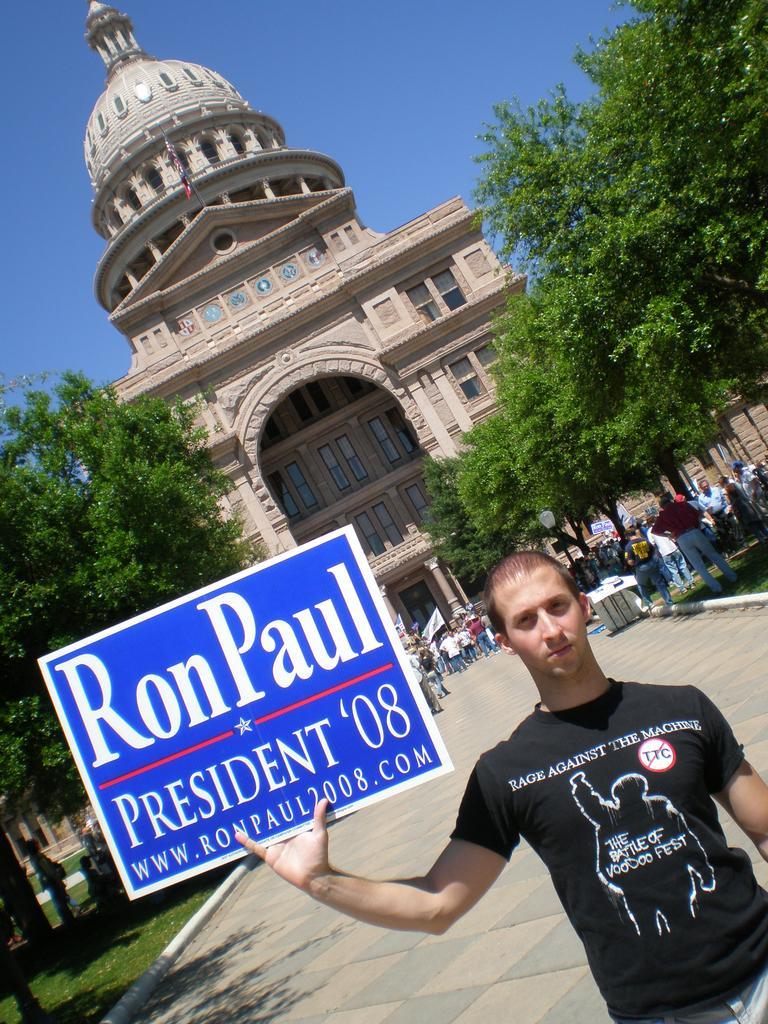In one or two sentences, can you explain what this image depicts? In this image we can see the building and in front of the building we can see the people standing and holding a flag. And there is the table, on the table there are a few objects. And we can see the person holding a board. There are trees, grass and the sky. 